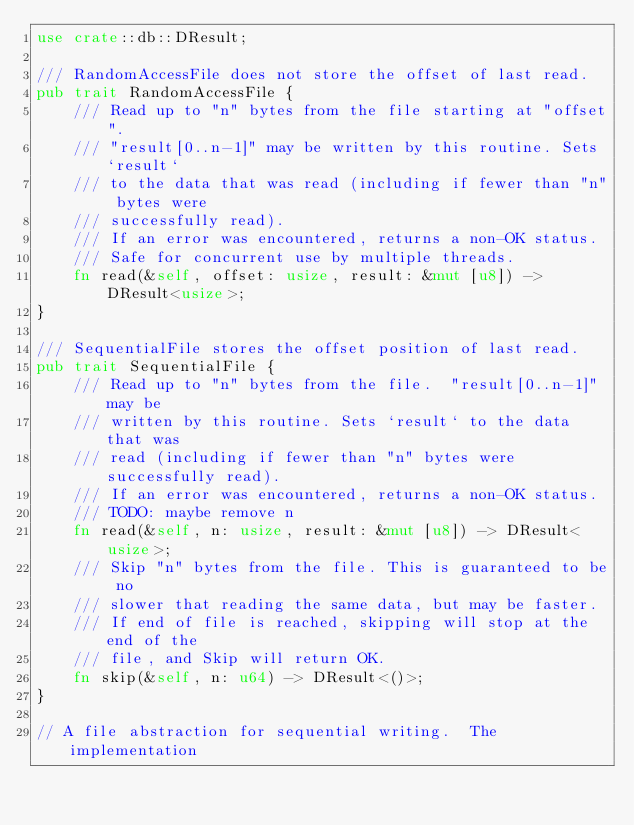Convert code to text. <code><loc_0><loc_0><loc_500><loc_500><_Rust_>use crate::db::DResult;

/// RandomAccessFile does not store the offset of last read.
pub trait RandomAccessFile {
    /// Read up to "n" bytes from the file starting at "offset".
    /// "result[0..n-1]" may be written by this routine. Sets `result`
    /// to the data that was read (including if fewer than "n" bytes were
    /// successfully read).
    /// If an error was encountered, returns a non-OK status.
    /// Safe for concurrent use by multiple threads.
    fn read(&self, offset: usize, result: &mut [u8]) -> DResult<usize>;
}

/// SequentialFile stores the offset position of last read.
pub trait SequentialFile {
    /// Read up to "n" bytes from the file.  "result[0..n-1]" may be
    /// written by this routine. Sets `result` to the data that was
    /// read (including if fewer than "n" bytes were successfully read).
    /// If an error was encountered, returns a non-OK status.
    /// TODO: maybe remove n
    fn read(&self, n: usize, result: &mut [u8]) -> DResult<usize>;
    /// Skip "n" bytes from the file. This is guaranteed to be no
    /// slower that reading the same data, but may be faster.
    /// If end of file is reached, skipping will stop at the end of the
    /// file, and Skip will return OK.
    fn skip(&self, n: u64) -> DResult<()>;
}

// A file abstraction for sequential writing.  The implementation</code> 